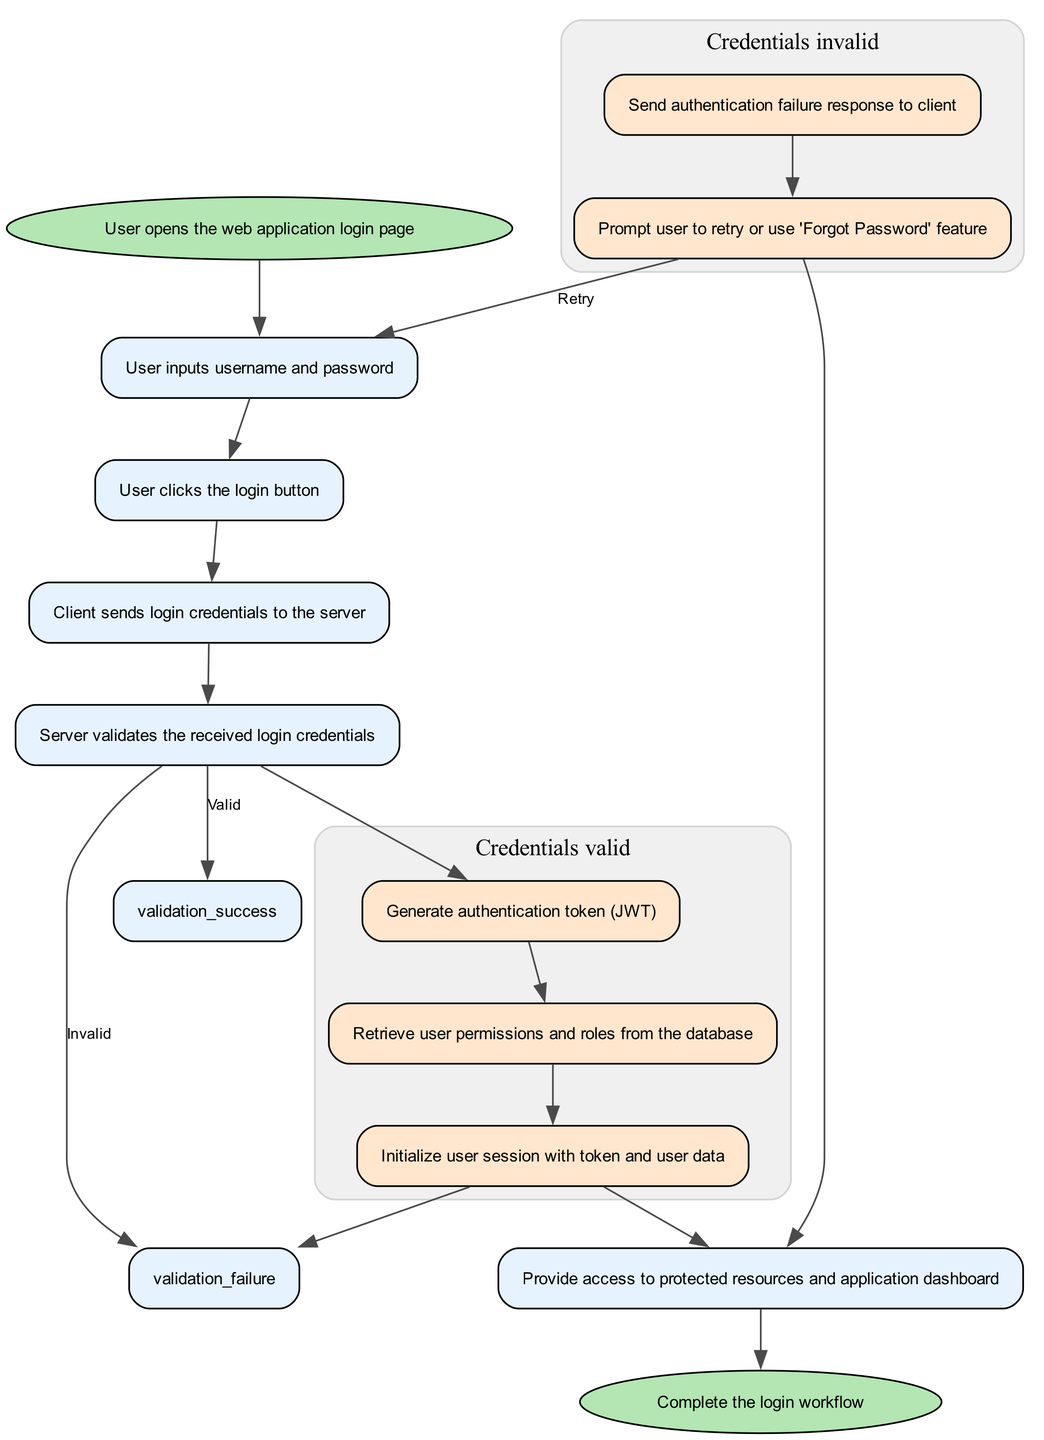What is the first step in the user authentication workflow? The first step is when the user opens the web application login page, as depicted at the beginning of the flowchart.
Answer: User opens the web application login page How many actions are taken if the validation of credentials fails? In the case of validation failure, there are two actions: sending an authentication failure response and prompting the user to retry or use 'Forgot Password'.
Answer: Two actions What happens after the user submits their credentials? After the user submits their credentials, the client sends the login credentials to the server for validation as the next step in the workflow.
Answer: Client sends login credentials to the server What does the server do if it validates the credentials successfully? Upon successful validation, the server generates an authentication token, retrieves user permissions and roles, and initializes the user session with these credentials.
Answer: Generate authentication token, retrieve user permissions and roles, initialize user session What is the ultimate outcome of the successful login process? The successful login process grants access to protected resources and the application dashboard.
Answer: Provide access to protected resources and application dashboard Which step follows the credential validation failure? After the credential validation failure, the next step involves prompting the user to retry their input or initiate the 'Forgot Password' feature.
Answer: Prompt user to retry or use 'Forgot Password' feature How many total nodes are present in the diagram? There are a total of eight nodes in the diagram that correspond to each step in the user authentication workflow.
Answer: Eight nodes What is the relationship between 'request validation' and 'validation failure'? The relationship is that if the credentials are invalid, the process moves to the validation failure step from the request validation step in the workflow.
Answer: Invalid What is the significance of the 'generate token' action? The 'generate token' action is significant as it creates the authentication token (JWT) necessary for user session management and securing subsequent requests.
Answer: Generate authentication token What option does the user have after failing to log in? After failing to log in, the user can either retry entering their credentials or utilize the 'Forgot Password' feature as indicated in the workflow.
Answer: Retry or use 'Forgot Password' feature 